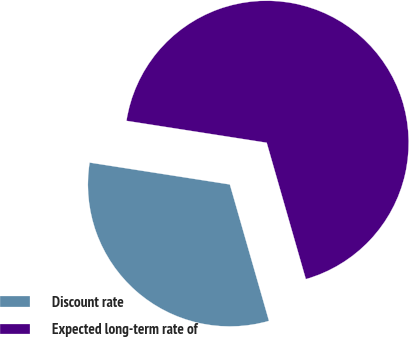Convert chart. <chart><loc_0><loc_0><loc_500><loc_500><pie_chart><fcel>Discount rate<fcel>Expected long-term rate of<nl><fcel>31.91%<fcel>68.09%<nl></chart> 